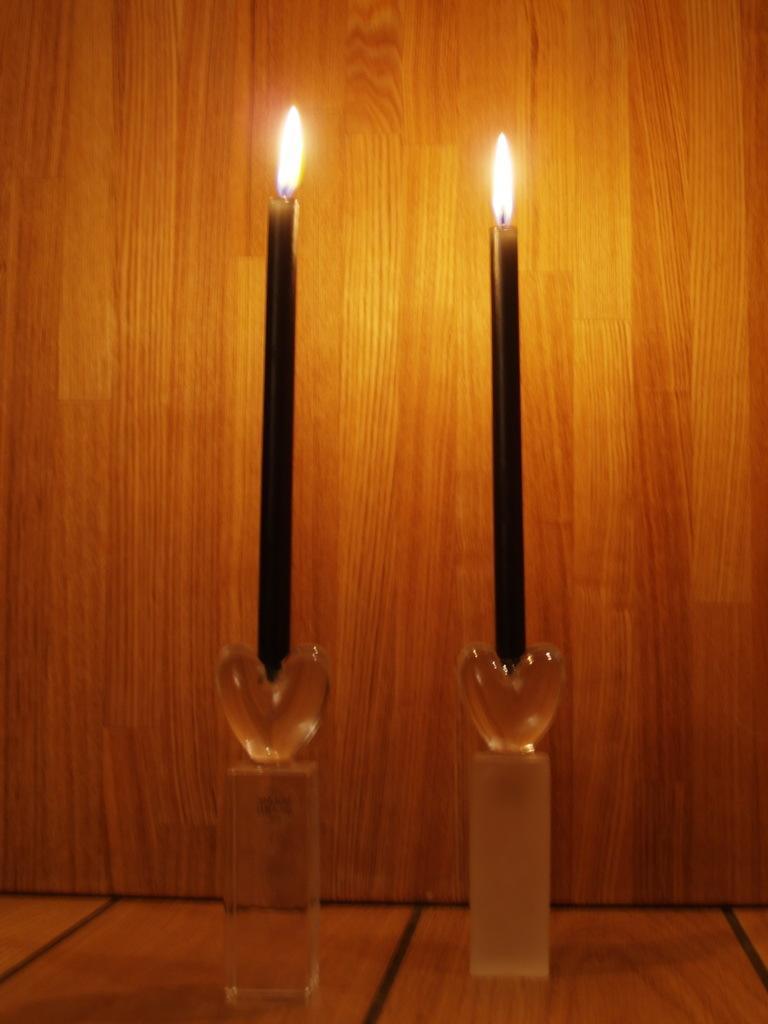In one or two sentences, can you explain what this image depicts? There are two candles with the flame on the candle stand. I think this is a wooden board. This is the floor. 